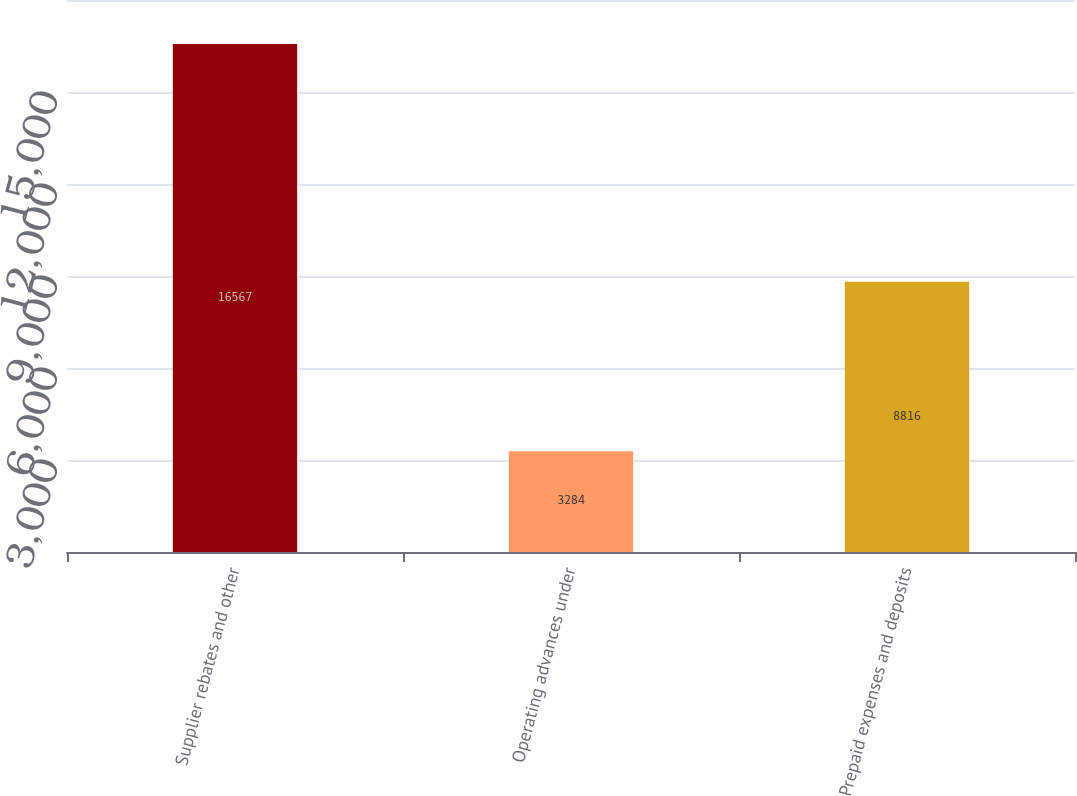Convert chart to OTSL. <chart><loc_0><loc_0><loc_500><loc_500><bar_chart><fcel>Supplier rebates and other<fcel>Operating advances under<fcel>Prepaid expenses and deposits<nl><fcel>16567<fcel>3284<fcel>8816<nl></chart> 